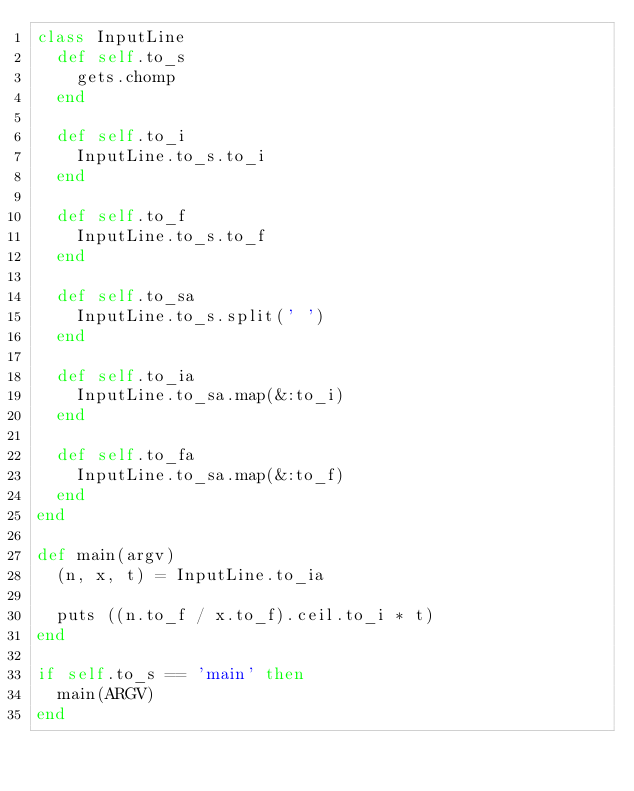<code> <loc_0><loc_0><loc_500><loc_500><_Ruby_>class InputLine
  def self.to_s
    gets.chomp
  end

  def self.to_i
    InputLine.to_s.to_i
  end
  
  def self.to_f
    InputLine.to_s.to_f
  end

  def self.to_sa
    InputLine.to_s.split(' ')
  end

  def self.to_ia
    InputLine.to_sa.map(&:to_i)
  end
  
  def self.to_fa
    InputLine.to_sa.map(&:to_f)
  end
end

def main(argv)
  (n, x, t) = InputLine.to_ia

  puts ((n.to_f / x.to_f).ceil.to_i * t)
end

if self.to_s == 'main' then
  main(ARGV)
end</code> 